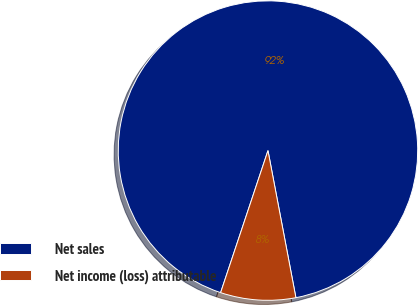Convert chart. <chart><loc_0><loc_0><loc_500><loc_500><pie_chart><fcel>Net sales<fcel>Net income (loss) attributable<nl><fcel>91.89%<fcel>8.11%<nl></chart> 